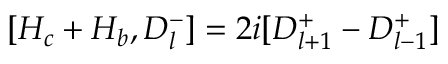Convert formula to latex. <formula><loc_0><loc_0><loc_500><loc_500>[ H _ { c } + H _ { b } , D _ { l } ^ { - } ] = 2 i [ D _ { l + 1 } ^ { + } - D _ { l - 1 } ^ { + } ]</formula> 